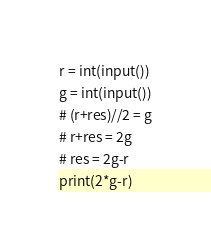Convert code to text. <code><loc_0><loc_0><loc_500><loc_500><_Python_>r = int(input())
g = int(input())
# (r+res)//2 = g
# r+res = 2g
# res = 2g-r
print(2*g-r)</code> 